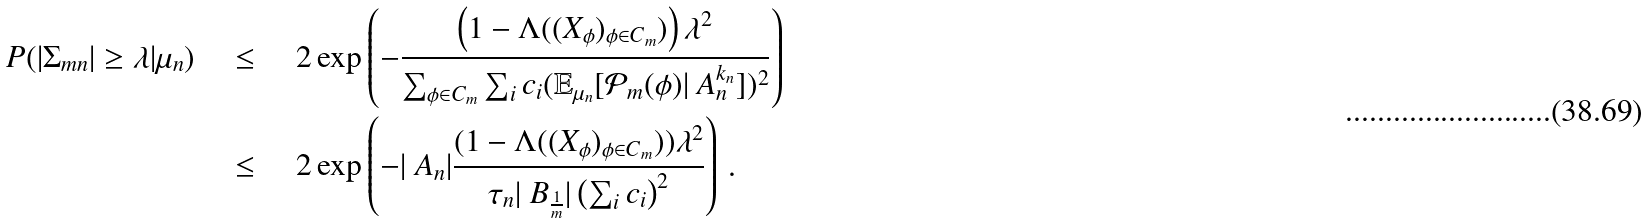<formula> <loc_0><loc_0><loc_500><loc_500>P ( | \Sigma _ { m n } | \geq \lambda | \mu _ { n } ) & \quad \leq \quad 2 \exp \left ( { - \frac { \left ( 1 - \Lambda ( ( X _ { \phi } ) _ { \phi \in C _ { m } } ) \right ) \lambda ^ { 2 } } { \sum _ { \phi \in C _ { m } } \sum _ { i } c _ { i } ( \mathbb { E } _ { \mu _ { n } } [ \mathcal { P } _ { m } ( \phi ) | \ A _ { n } ^ { k _ { n } } ] ) ^ { 2 } } } \right ) \\ & \quad \leq \quad 2 \exp \left ( - | \ A _ { n } | \frac { ( 1 - \Lambda ( ( X _ { \phi } ) _ { \phi \in C _ { m } } ) ) \lambda ^ { 2 } } { \tau _ { n } | \ B _ { \frac { 1 } { m } } | \left ( \sum _ { i } c _ { i } \right ) ^ { 2 } } \right ) \, .</formula> 